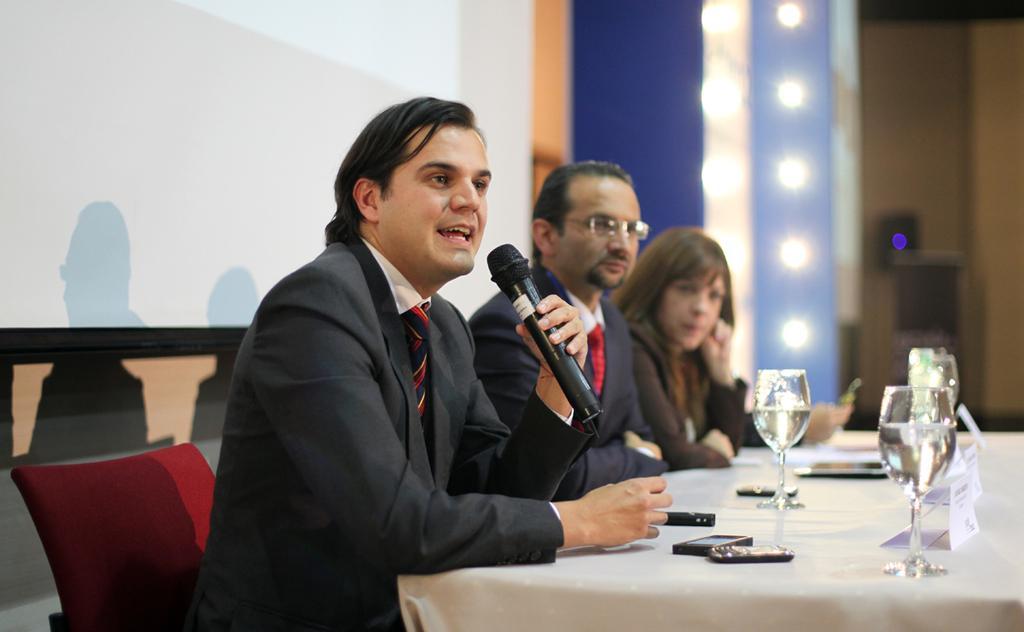Could you give a brief overview of what you see in this image? On the left side a man is sitting on the chair and speaking in the microphone, he wore coat, there are glasses on this table. Beside him another man is there and a woman. 